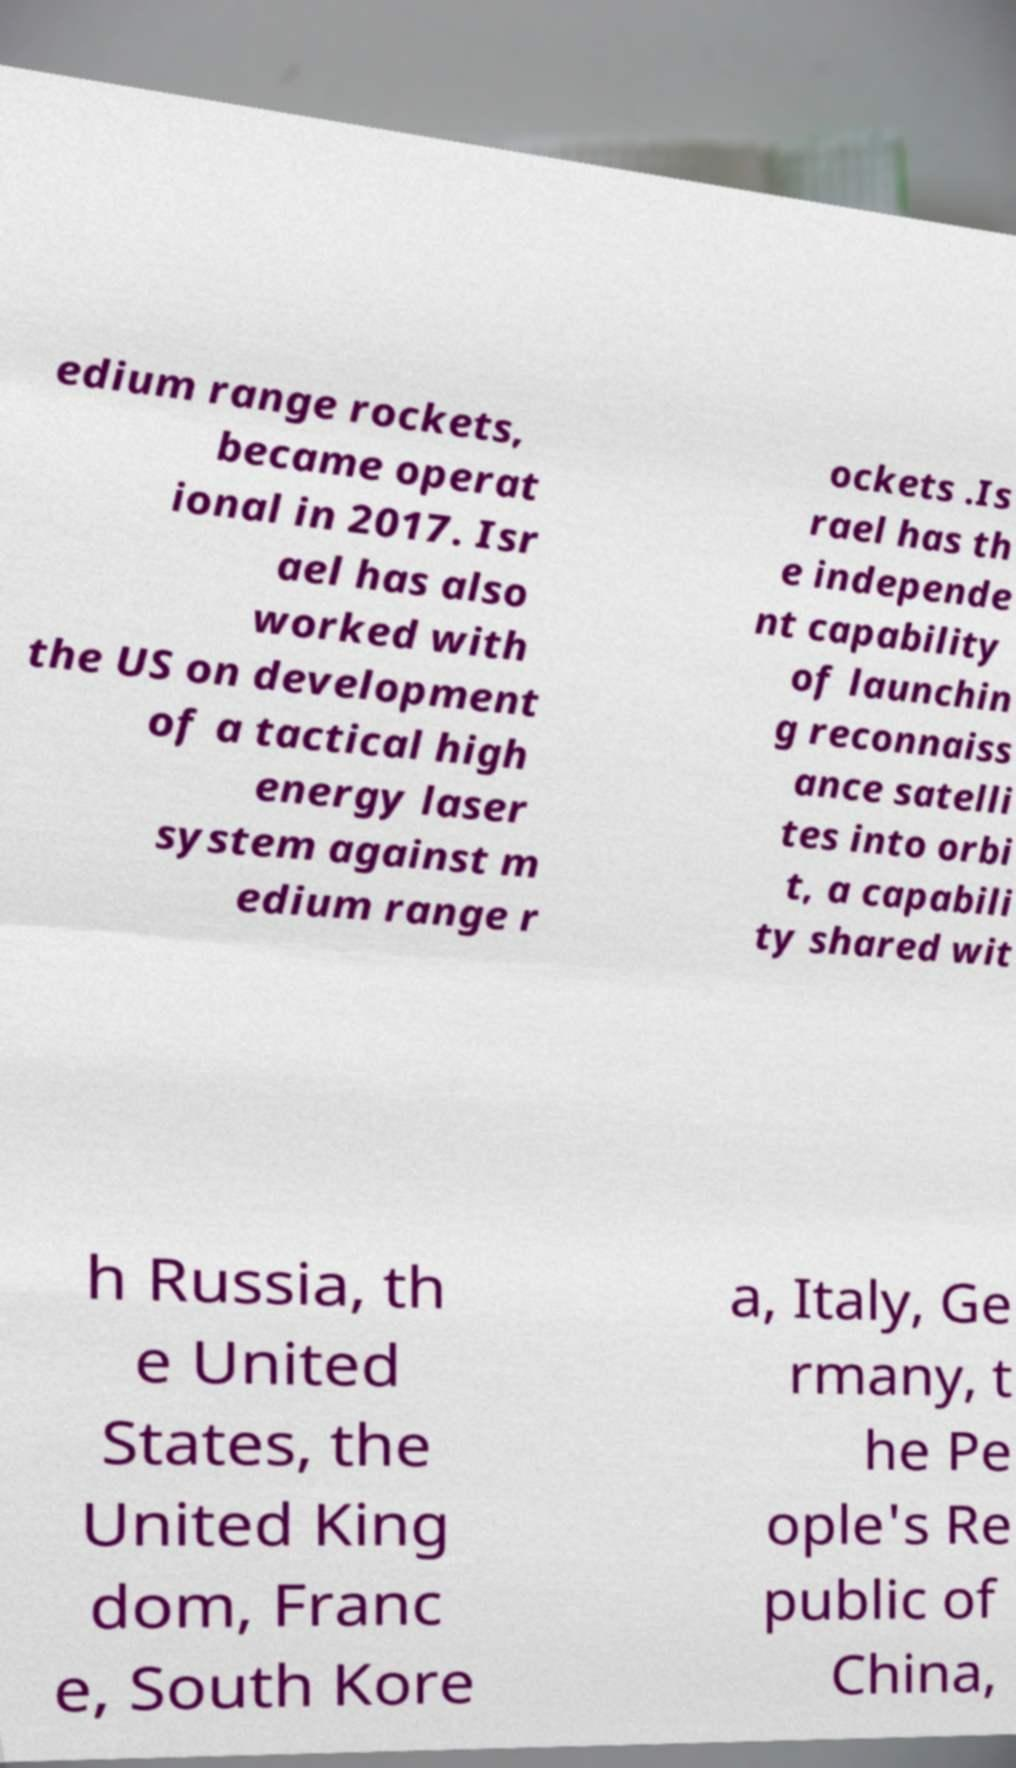Please read and relay the text visible in this image. What does it say? edium range rockets, became operat ional in 2017. Isr ael has also worked with the US on development of a tactical high energy laser system against m edium range r ockets .Is rael has th e independe nt capability of launchin g reconnaiss ance satelli tes into orbi t, a capabili ty shared wit h Russia, th e United States, the United King dom, Franc e, South Kore a, Italy, Ge rmany, t he Pe ople's Re public of China, 